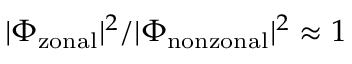<formula> <loc_0><loc_0><loc_500><loc_500>| \Phi _ { z o n a l } | ^ { 2 } / | \Phi _ { n o n z o n a l } | ^ { 2 } \approx 1</formula> 